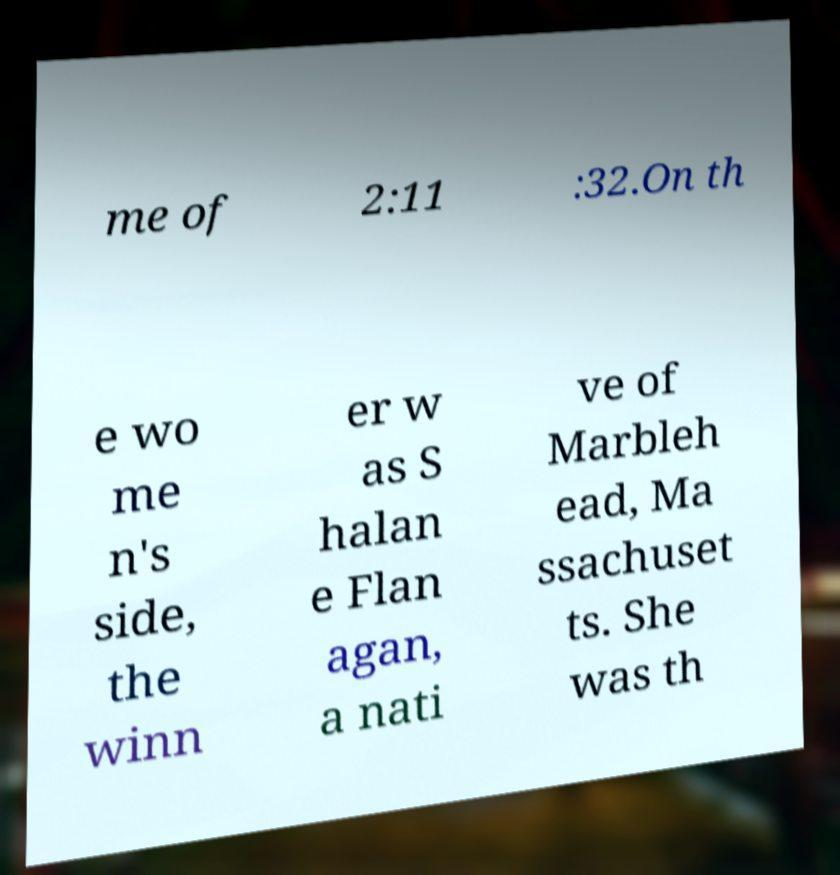Could you assist in decoding the text presented in this image and type it out clearly? me of 2:11 :32.On th e wo me n's side, the winn er w as S halan e Flan agan, a nati ve of Marbleh ead, Ma ssachuset ts. She was th 